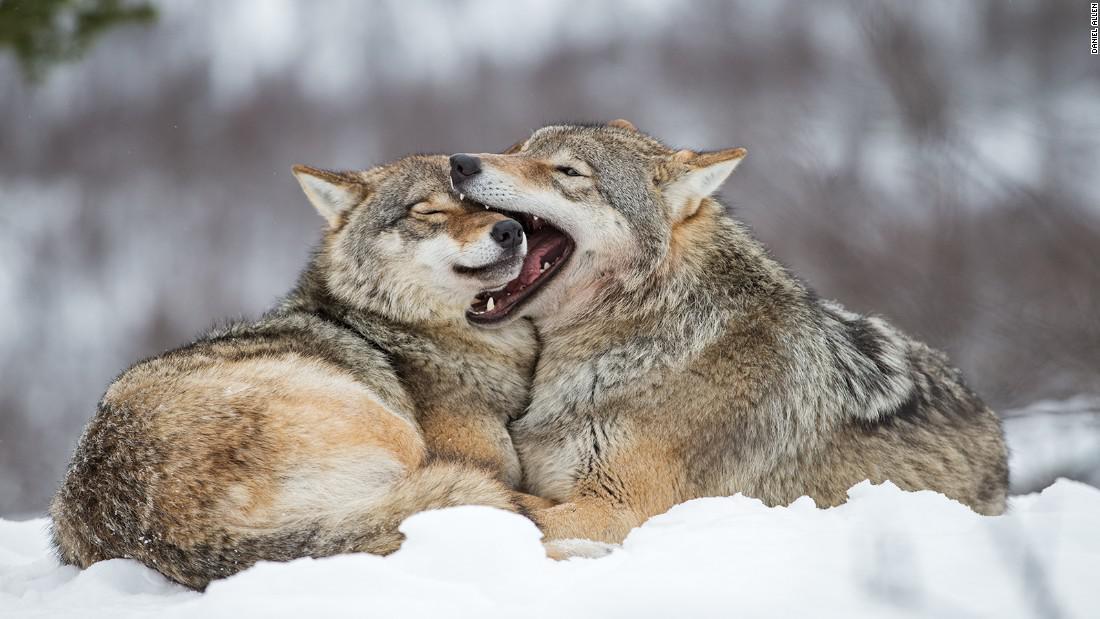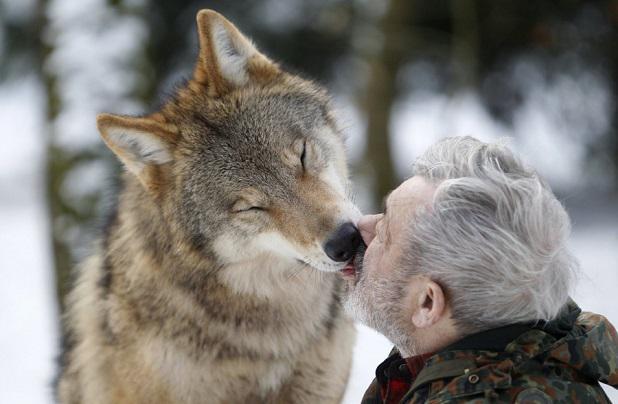The first image is the image on the left, the second image is the image on the right. Given the left and right images, does the statement "At least one wolf is using their tongue to kiss." hold true? Answer yes or no. Yes. The first image is the image on the left, the second image is the image on the right. Examine the images to the left and right. Is the description "You can see a wolf's tongue." accurate? Answer yes or no. Yes. 